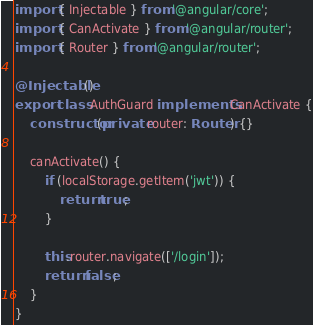<code> <loc_0><loc_0><loc_500><loc_500><_TypeScript_>import { Injectable } from '@angular/core';
import { CanActivate } from '@angular/router';
import { Router } from '@angular/router';

@Injectable()
export class AuthGuard implements CanActivate {
    constructor(private router: Router) {}

    canActivate() {
        if (localStorage.getItem('jwt')) {
            return true;
        }

        this.router.navigate(['/login']);
        return false;
    }
}
</code> 